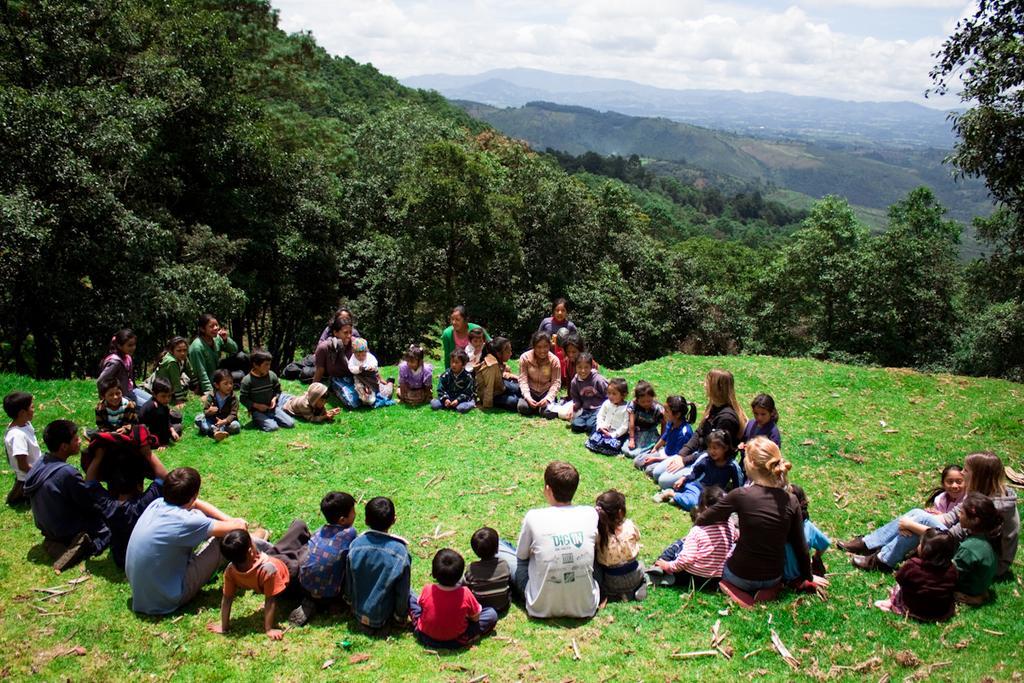Could you give a brief overview of what you see in this image? In this picture I can see the group of persons were sitting around in the grass. In the bottom right I can see the children's were sitting near to the woman. Beside them I can see the leaves. In the background I can see many trees and mountains. At the top I can see the sky and clouds. 